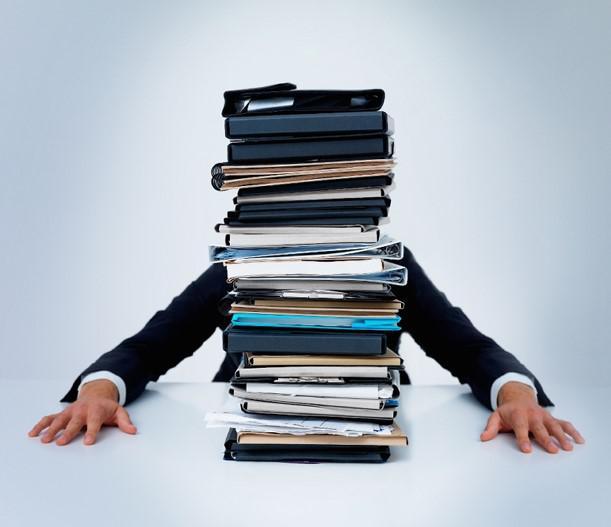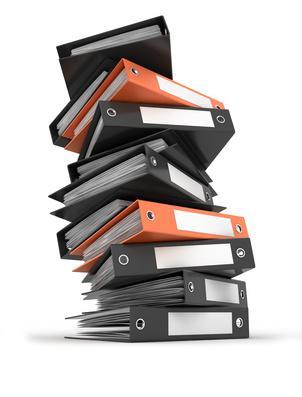The first image is the image on the left, the second image is the image on the right. Examine the images to the left and right. Is the description "In one image all the binders are red." accurate? Answer yes or no. No. The first image is the image on the left, the second image is the image on the right. Given the left and right images, does the statement "There is a collection of red binders." hold true? Answer yes or no. No. 